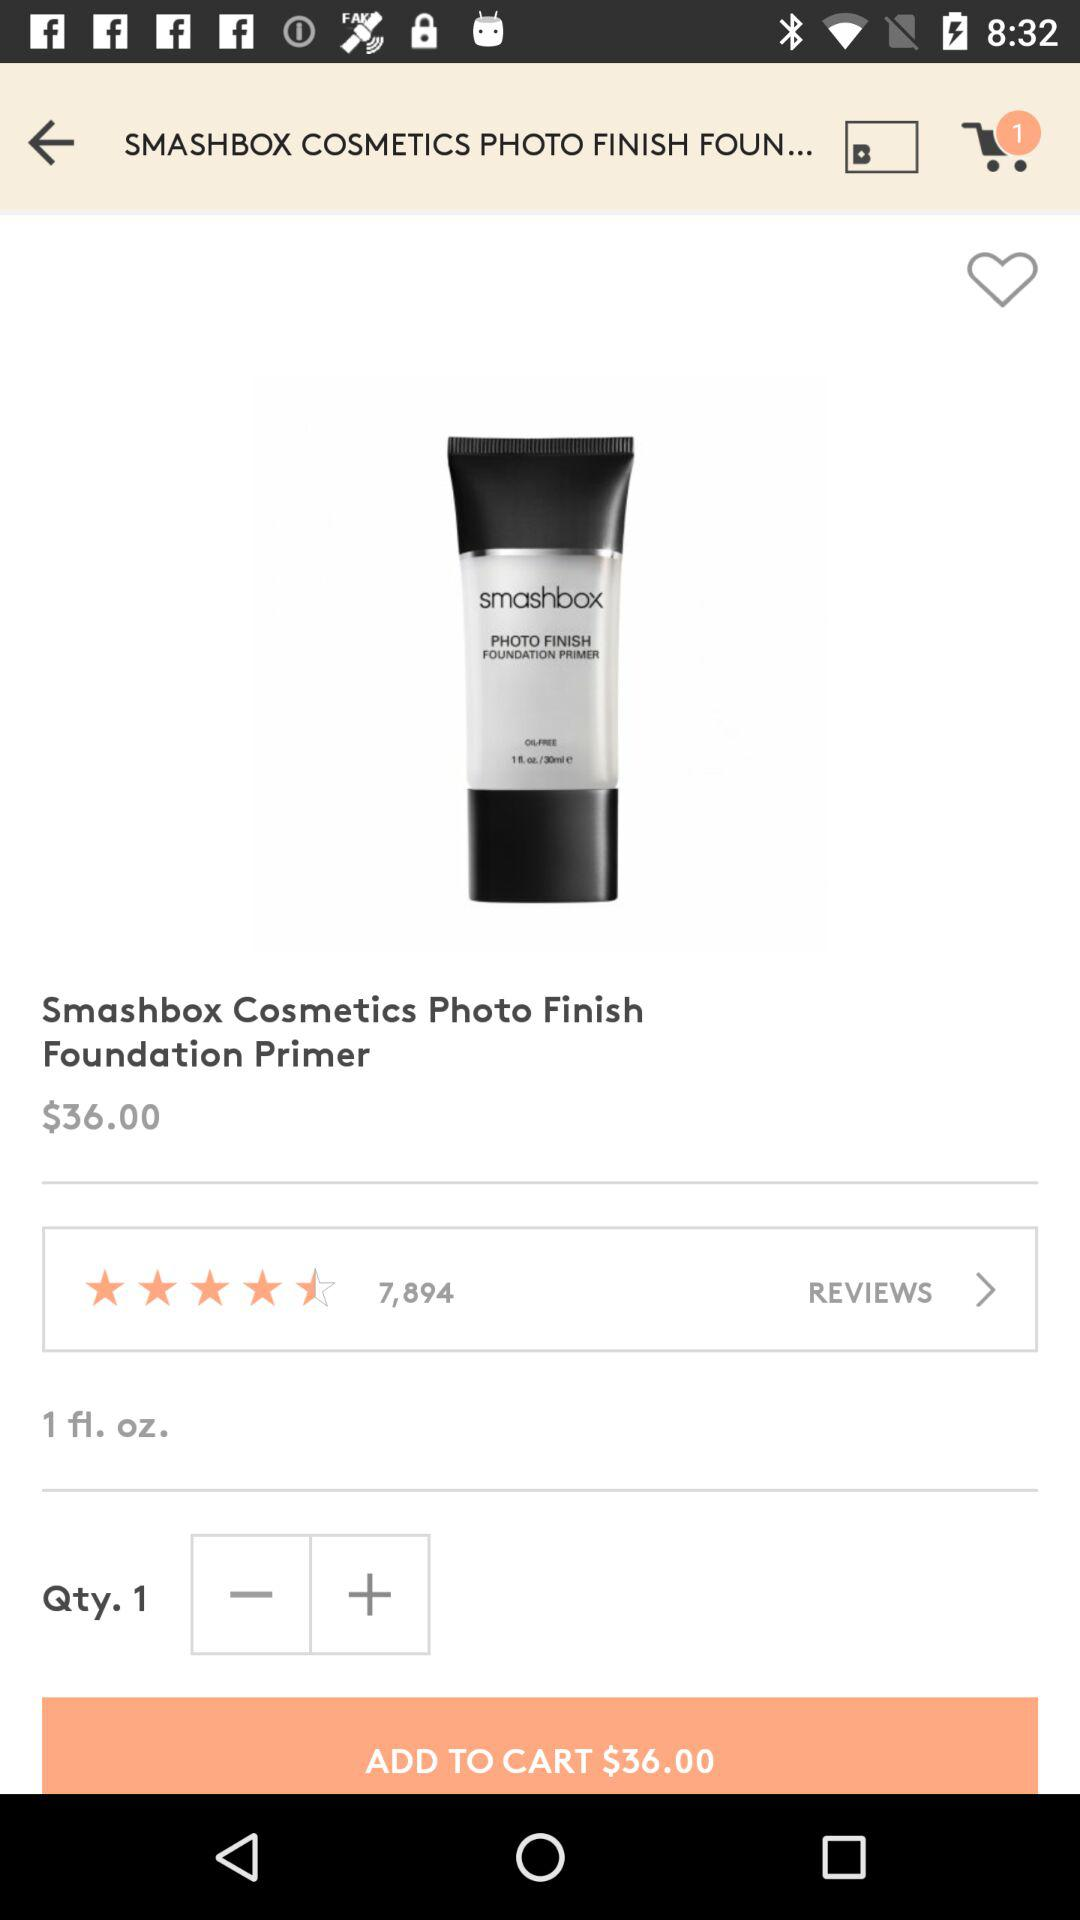What is the price of the product?
Answer the question using a single word or phrase. $36.00 